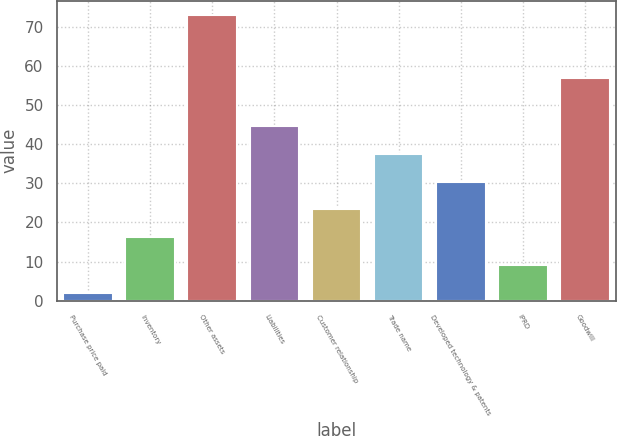Convert chart to OTSL. <chart><loc_0><loc_0><loc_500><loc_500><bar_chart><fcel>Purchase price paid<fcel>Inventory<fcel>Other assets<fcel>Liabilities<fcel>Customer relationship<fcel>Trade name<fcel>Developed technology & patents<fcel>IPRD<fcel>Goodwill<nl><fcel>2<fcel>16.2<fcel>73<fcel>44.6<fcel>23.3<fcel>37.5<fcel>30.4<fcel>9.1<fcel>57<nl></chart> 